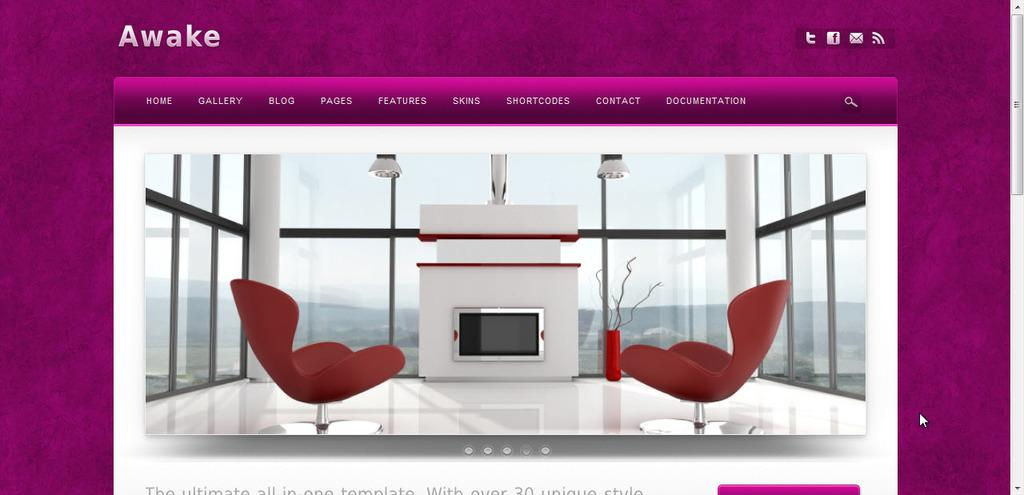<image>
Create a compact narrative representing the image presented. A web page for Awake shows a living space with red chairs and a fireplace. 